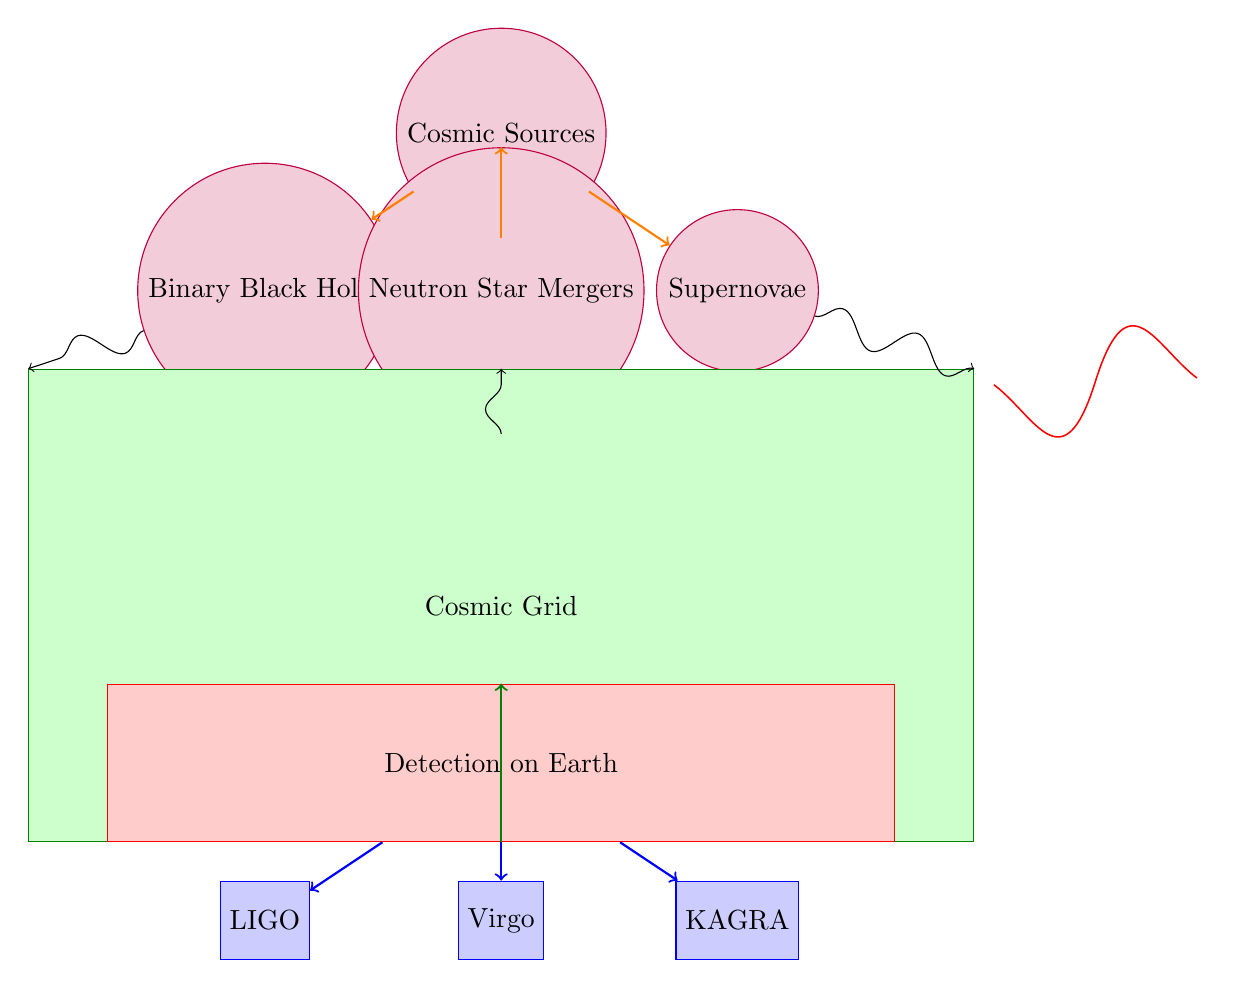What are the three types of cosmic sources depicted in the diagram? The diagram shows three cosmic sources: Binary Black Holes, Neutron Star Mergers, and Supernovae. These are listed directly under the "Cosmic Sources" node.
Answer: Binary Black Holes, Neutron Star Mergers, Supernovae How many detectors are shown in this diagram? The diagram includes three detectors: LIGO, Virgo, and KAGRA. This count can be verified by counting the detector nodes at the bottom of the diagram.
Answer: 3 What color represents the "Detection on Earth" node? The "Detection on Earth" node is colored red in the diagram, which can be identified by observing the fill color of the rectangular node labeled “Detection on Earth.”
Answer: Red Which cosmic source has an arrow directed downward to the grid? The Neutron Star Mergers node has an arrow directed downward towards the Cosmic Grid, indicating its connection in the flow of gravitational waves as shown in the diagram.
Answer: Neutron Star Mergers Describe the flow direction of the gravitational waves from the sources to the detection. The flow of gravitational waves moves from the cosmic sources at the top of the diagram downwards through the Cosmic Grid, and then further directed towards the detectors (LIGO, Virgo, KAGRA) at the bottom. This directional flow is shown by the arrows throughout the diagram.
Answer: Downwards What does the waveform plot represent in the context of gravitational waves? The waveform plot represents the signal or pattern of the gravitational waves as they travel through space and time, typically depicting the amplitude over a range of values. It reflects the nature of waves generated from cosmic events illustrated above.
Answer: Waveform Plot From which cosmic source does the orange arrow indicating gravitational waves derive upward toward the Cosmic Grid? The orange arrows indicate that gravitational waves derive upward from each cosmic source: Binary Black Holes, Neutron Star Mergers, and Supernovae, joining at the Cosmic Grid. This directional flow emphasizes their connection to gravitational wave detection.
Answer: All cosmic sources What does the green rectangle in the diagram represent? The green rectangle represents the Cosmic Grid, which plays a crucial role as a medium through which gravitational waves pass on their way to detection on Earth. This is illustrated by the labeling and the color of the node.
Answer: Cosmic Grid 